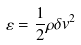Convert formula to latex. <formula><loc_0><loc_0><loc_500><loc_500>\varepsilon = \frac { 1 } { 2 } \rho \delta v ^ { 2 }</formula> 